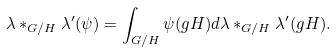Convert formula to latex. <formula><loc_0><loc_0><loc_500><loc_500>\lambda \ast _ { G / H } \lambda ^ { \prime } ( \psi ) = \int _ { G / H } \psi ( g H ) d \lambda \ast _ { G / H } \lambda ^ { \prime } ( g H ) .</formula> 